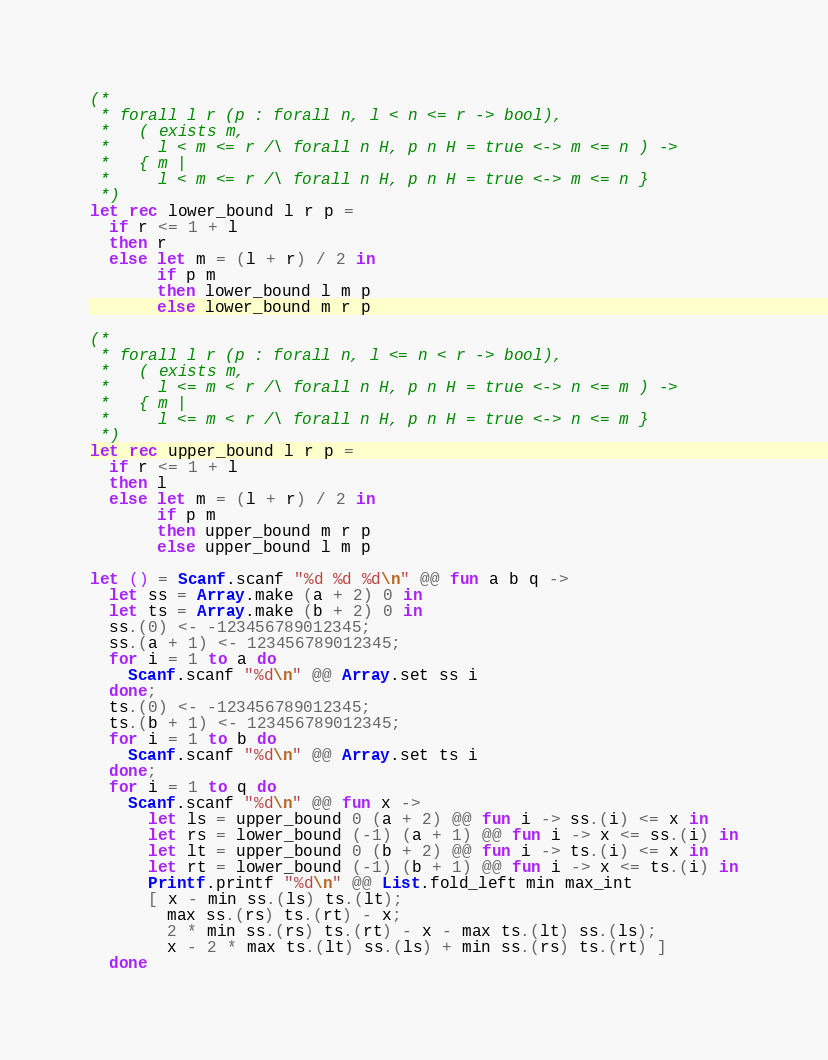<code> <loc_0><loc_0><loc_500><loc_500><_OCaml_>(*
 * forall l r (p : forall n, l < n <= r -> bool),
 *   ( exists m,
 *     l < m <= r /\ forall n H, p n H = true <-> m <= n ) ->
 *   { m |
 *     l < m <= r /\ forall n H, p n H = true <-> m <= n }
 *)
let rec lower_bound l r p =
  if r <= 1 + l
  then r
  else let m = (l + r) / 2 in
       if p m
       then lower_bound l m p
       else lower_bound m r p

(*
 * forall l r (p : forall n, l <= n < r -> bool),
 *   ( exists m,
 *     l <= m < r /\ forall n H, p n H = true <-> n <= m ) ->
 *   { m |
 *     l <= m < r /\ forall n H, p n H = true <-> n <= m }
 *)
let rec upper_bound l r p =
  if r <= 1 + l
  then l
  else let m = (l + r) / 2 in
       if p m
       then upper_bound m r p
       else upper_bound l m p

let () = Scanf.scanf "%d %d %d\n" @@ fun a b q ->
  let ss = Array.make (a + 2) 0 in
  let ts = Array.make (b + 2) 0 in
  ss.(0) <- -123456789012345;
  ss.(a + 1) <- 123456789012345;
  for i = 1 to a do
    Scanf.scanf "%d\n" @@ Array.set ss i
  done;
  ts.(0) <- -123456789012345;
  ts.(b + 1) <- 123456789012345;
  for i = 1 to b do
    Scanf.scanf "%d\n" @@ Array.set ts i
  done;
  for i = 1 to q do
    Scanf.scanf "%d\n" @@ fun x ->
      let ls = upper_bound 0 (a + 2) @@ fun i -> ss.(i) <= x in
      let rs = lower_bound (-1) (a + 1) @@ fun i -> x <= ss.(i) in
      let lt = upper_bound 0 (b + 2) @@ fun i -> ts.(i) <= x in
      let rt = lower_bound (-1) (b + 1) @@ fun i -> x <= ts.(i) in
      Printf.printf "%d\n" @@ List.fold_left min max_int
      [ x - min ss.(ls) ts.(lt);
        max ss.(rs) ts.(rt) - x;
        2 * min ss.(rs) ts.(rt) - x - max ts.(lt) ss.(ls);
        x - 2 * max ts.(lt) ss.(ls) + min ss.(rs) ts.(rt) ]
  done</code> 